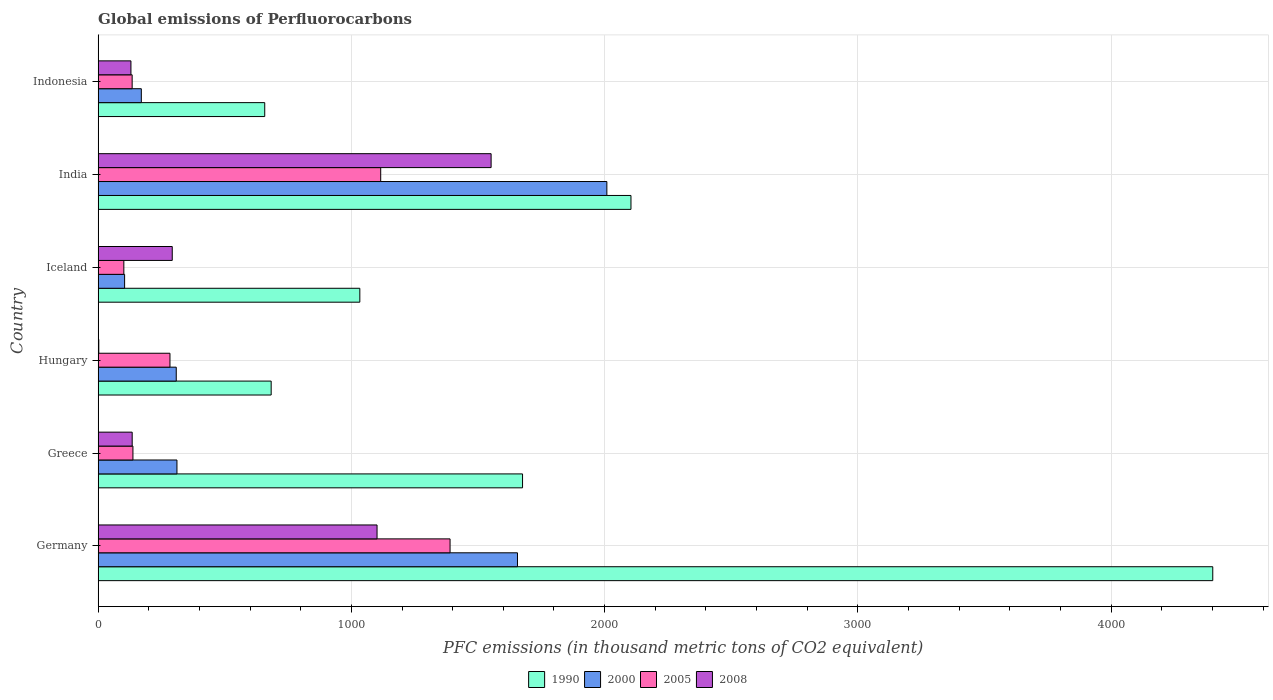Are the number of bars per tick equal to the number of legend labels?
Offer a very short reply. Yes. How many bars are there on the 4th tick from the top?
Provide a succinct answer. 4. What is the label of the 4th group of bars from the top?
Offer a very short reply. Hungary. What is the global emissions of Perfluorocarbons in 2005 in Iceland?
Offer a terse response. 101.6. Across all countries, what is the maximum global emissions of Perfluorocarbons in 2008?
Ensure brevity in your answer.  1551.8. Across all countries, what is the minimum global emissions of Perfluorocarbons in 2005?
Your answer should be compact. 101.6. What is the total global emissions of Perfluorocarbons in 2008 in the graph?
Your answer should be very brief. 3212.7. What is the difference between the global emissions of Perfluorocarbons in 1990 in Greece and that in India?
Ensure brevity in your answer.  -428.1. What is the difference between the global emissions of Perfluorocarbons in 2008 in India and the global emissions of Perfluorocarbons in 2005 in Hungary?
Keep it short and to the point. 1268.1. What is the average global emissions of Perfluorocarbons in 1990 per country?
Give a very brief answer. 1759.3. What is the difference between the global emissions of Perfluorocarbons in 2000 and global emissions of Perfluorocarbons in 2008 in Iceland?
Offer a terse response. -188.1. What is the ratio of the global emissions of Perfluorocarbons in 2000 in Greece to that in India?
Make the answer very short. 0.15. Is the difference between the global emissions of Perfluorocarbons in 2000 in Germany and Greece greater than the difference between the global emissions of Perfluorocarbons in 2008 in Germany and Greece?
Provide a succinct answer. Yes. What is the difference between the highest and the second highest global emissions of Perfluorocarbons in 2000?
Your answer should be compact. 352.9. What is the difference between the highest and the lowest global emissions of Perfluorocarbons in 2008?
Offer a very short reply. 1549.1. In how many countries, is the global emissions of Perfluorocarbons in 1990 greater than the average global emissions of Perfluorocarbons in 1990 taken over all countries?
Ensure brevity in your answer.  2. Is it the case that in every country, the sum of the global emissions of Perfluorocarbons in 2000 and global emissions of Perfluorocarbons in 2008 is greater than the sum of global emissions of Perfluorocarbons in 2005 and global emissions of Perfluorocarbons in 1990?
Your response must be concise. No. What does the 4th bar from the top in Hungary represents?
Provide a short and direct response. 1990. How many bars are there?
Offer a terse response. 24. Are all the bars in the graph horizontal?
Provide a short and direct response. Yes. What is the difference between two consecutive major ticks on the X-axis?
Provide a short and direct response. 1000. Are the values on the major ticks of X-axis written in scientific E-notation?
Make the answer very short. No. What is the title of the graph?
Keep it short and to the point. Global emissions of Perfluorocarbons. What is the label or title of the X-axis?
Make the answer very short. PFC emissions (in thousand metric tons of CO2 equivalent). What is the PFC emissions (in thousand metric tons of CO2 equivalent) in 1990 in Germany?
Give a very brief answer. 4401.3. What is the PFC emissions (in thousand metric tons of CO2 equivalent) of 2000 in Germany?
Give a very brief answer. 1655.9. What is the PFC emissions (in thousand metric tons of CO2 equivalent) in 2005 in Germany?
Offer a terse response. 1389.7. What is the PFC emissions (in thousand metric tons of CO2 equivalent) of 2008 in Germany?
Provide a short and direct response. 1101.4. What is the PFC emissions (in thousand metric tons of CO2 equivalent) of 1990 in Greece?
Your answer should be compact. 1675.9. What is the PFC emissions (in thousand metric tons of CO2 equivalent) of 2000 in Greece?
Ensure brevity in your answer.  311.3. What is the PFC emissions (in thousand metric tons of CO2 equivalent) in 2005 in Greece?
Your answer should be very brief. 137.5. What is the PFC emissions (in thousand metric tons of CO2 equivalent) in 2008 in Greece?
Your response must be concise. 134.5. What is the PFC emissions (in thousand metric tons of CO2 equivalent) in 1990 in Hungary?
Give a very brief answer. 683.3. What is the PFC emissions (in thousand metric tons of CO2 equivalent) in 2000 in Hungary?
Your answer should be very brief. 308.5. What is the PFC emissions (in thousand metric tons of CO2 equivalent) in 2005 in Hungary?
Offer a very short reply. 283.7. What is the PFC emissions (in thousand metric tons of CO2 equivalent) of 1990 in Iceland?
Make the answer very short. 1033.4. What is the PFC emissions (in thousand metric tons of CO2 equivalent) of 2000 in Iceland?
Make the answer very short. 104.6. What is the PFC emissions (in thousand metric tons of CO2 equivalent) of 2005 in Iceland?
Keep it short and to the point. 101.6. What is the PFC emissions (in thousand metric tons of CO2 equivalent) in 2008 in Iceland?
Ensure brevity in your answer.  292.7. What is the PFC emissions (in thousand metric tons of CO2 equivalent) in 1990 in India?
Offer a terse response. 2104. What is the PFC emissions (in thousand metric tons of CO2 equivalent) of 2000 in India?
Your answer should be very brief. 2008.8. What is the PFC emissions (in thousand metric tons of CO2 equivalent) of 2005 in India?
Ensure brevity in your answer.  1115.8. What is the PFC emissions (in thousand metric tons of CO2 equivalent) in 2008 in India?
Provide a succinct answer. 1551.8. What is the PFC emissions (in thousand metric tons of CO2 equivalent) in 1990 in Indonesia?
Make the answer very short. 657.9. What is the PFC emissions (in thousand metric tons of CO2 equivalent) in 2000 in Indonesia?
Give a very brief answer. 170.6. What is the PFC emissions (in thousand metric tons of CO2 equivalent) of 2005 in Indonesia?
Your response must be concise. 134.4. What is the PFC emissions (in thousand metric tons of CO2 equivalent) of 2008 in Indonesia?
Make the answer very short. 129.6. Across all countries, what is the maximum PFC emissions (in thousand metric tons of CO2 equivalent) of 1990?
Make the answer very short. 4401.3. Across all countries, what is the maximum PFC emissions (in thousand metric tons of CO2 equivalent) of 2000?
Offer a very short reply. 2008.8. Across all countries, what is the maximum PFC emissions (in thousand metric tons of CO2 equivalent) of 2005?
Offer a very short reply. 1389.7. Across all countries, what is the maximum PFC emissions (in thousand metric tons of CO2 equivalent) of 2008?
Your answer should be very brief. 1551.8. Across all countries, what is the minimum PFC emissions (in thousand metric tons of CO2 equivalent) of 1990?
Give a very brief answer. 657.9. Across all countries, what is the minimum PFC emissions (in thousand metric tons of CO2 equivalent) of 2000?
Offer a very short reply. 104.6. Across all countries, what is the minimum PFC emissions (in thousand metric tons of CO2 equivalent) in 2005?
Your answer should be very brief. 101.6. Across all countries, what is the minimum PFC emissions (in thousand metric tons of CO2 equivalent) in 2008?
Ensure brevity in your answer.  2.7. What is the total PFC emissions (in thousand metric tons of CO2 equivalent) of 1990 in the graph?
Offer a terse response. 1.06e+04. What is the total PFC emissions (in thousand metric tons of CO2 equivalent) of 2000 in the graph?
Ensure brevity in your answer.  4559.7. What is the total PFC emissions (in thousand metric tons of CO2 equivalent) of 2005 in the graph?
Keep it short and to the point. 3162.7. What is the total PFC emissions (in thousand metric tons of CO2 equivalent) in 2008 in the graph?
Make the answer very short. 3212.7. What is the difference between the PFC emissions (in thousand metric tons of CO2 equivalent) in 1990 in Germany and that in Greece?
Provide a succinct answer. 2725.4. What is the difference between the PFC emissions (in thousand metric tons of CO2 equivalent) of 2000 in Germany and that in Greece?
Offer a terse response. 1344.6. What is the difference between the PFC emissions (in thousand metric tons of CO2 equivalent) in 2005 in Germany and that in Greece?
Your answer should be compact. 1252.2. What is the difference between the PFC emissions (in thousand metric tons of CO2 equivalent) in 2008 in Germany and that in Greece?
Make the answer very short. 966.9. What is the difference between the PFC emissions (in thousand metric tons of CO2 equivalent) of 1990 in Germany and that in Hungary?
Your answer should be very brief. 3718. What is the difference between the PFC emissions (in thousand metric tons of CO2 equivalent) in 2000 in Germany and that in Hungary?
Keep it short and to the point. 1347.4. What is the difference between the PFC emissions (in thousand metric tons of CO2 equivalent) in 2005 in Germany and that in Hungary?
Make the answer very short. 1106. What is the difference between the PFC emissions (in thousand metric tons of CO2 equivalent) of 2008 in Germany and that in Hungary?
Give a very brief answer. 1098.7. What is the difference between the PFC emissions (in thousand metric tons of CO2 equivalent) of 1990 in Germany and that in Iceland?
Your answer should be very brief. 3367.9. What is the difference between the PFC emissions (in thousand metric tons of CO2 equivalent) of 2000 in Germany and that in Iceland?
Give a very brief answer. 1551.3. What is the difference between the PFC emissions (in thousand metric tons of CO2 equivalent) in 2005 in Germany and that in Iceland?
Offer a terse response. 1288.1. What is the difference between the PFC emissions (in thousand metric tons of CO2 equivalent) of 2008 in Germany and that in Iceland?
Offer a terse response. 808.7. What is the difference between the PFC emissions (in thousand metric tons of CO2 equivalent) in 1990 in Germany and that in India?
Ensure brevity in your answer.  2297.3. What is the difference between the PFC emissions (in thousand metric tons of CO2 equivalent) of 2000 in Germany and that in India?
Provide a succinct answer. -352.9. What is the difference between the PFC emissions (in thousand metric tons of CO2 equivalent) of 2005 in Germany and that in India?
Your response must be concise. 273.9. What is the difference between the PFC emissions (in thousand metric tons of CO2 equivalent) of 2008 in Germany and that in India?
Make the answer very short. -450.4. What is the difference between the PFC emissions (in thousand metric tons of CO2 equivalent) of 1990 in Germany and that in Indonesia?
Your response must be concise. 3743.4. What is the difference between the PFC emissions (in thousand metric tons of CO2 equivalent) of 2000 in Germany and that in Indonesia?
Offer a terse response. 1485.3. What is the difference between the PFC emissions (in thousand metric tons of CO2 equivalent) of 2005 in Germany and that in Indonesia?
Keep it short and to the point. 1255.3. What is the difference between the PFC emissions (in thousand metric tons of CO2 equivalent) of 2008 in Germany and that in Indonesia?
Provide a succinct answer. 971.8. What is the difference between the PFC emissions (in thousand metric tons of CO2 equivalent) of 1990 in Greece and that in Hungary?
Offer a very short reply. 992.6. What is the difference between the PFC emissions (in thousand metric tons of CO2 equivalent) of 2005 in Greece and that in Hungary?
Make the answer very short. -146.2. What is the difference between the PFC emissions (in thousand metric tons of CO2 equivalent) in 2008 in Greece and that in Hungary?
Your response must be concise. 131.8. What is the difference between the PFC emissions (in thousand metric tons of CO2 equivalent) of 1990 in Greece and that in Iceland?
Your answer should be very brief. 642.5. What is the difference between the PFC emissions (in thousand metric tons of CO2 equivalent) of 2000 in Greece and that in Iceland?
Your answer should be very brief. 206.7. What is the difference between the PFC emissions (in thousand metric tons of CO2 equivalent) in 2005 in Greece and that in Iceland?
Provide a short and direct response. 35.9. What is the difference between the PFC emissions (in thousand metric tons of CO2 equivalent) in 2008 in Greece and that in Iceland?
Offer a terse response. -158.2. What is the difference between the PFC emissions (in thousand metric tons of CO2 equivalent) in 1990 in Greece and that in India?
Make the answer very short. -428.1. What is the difference between the PFC emissions (in thousand metric tons of CO2 equivalent) in 2000 in Greece and that in India?
Provide a short and direct response. -1697.5. What is the difference between the PFC emissions (in thousand metric tons of CO2 equivalent) of 2005 in Greece and that in India?
Offer a very short reply. -978.3. What is the difference between the PFC emissions (in thousand metric tons of CO2 equivalent) of 2008 in Greece and that in India?
Give a very brief answer. -1417.3. What is the difference between the PFC emissions (in thousand metric tons of CO2 equivalent) of 1990 in Greece and that in Indonesia?
Offer a very short reply. 1018. What is the difference between the PFC emissions (in thousand metric tons of CO2 equivalent) in 2000 in Greece and that in Indonesia?
Your answer should be very brief. 140.7. What is the difference between the PFC emissions (in thousand metric tons of CO2 equivalent) of 2005 in Greece and that in Indonesia?
Make the answer very short. 3.1. What is the difference between the PFC emissions (in thousand metric tons of CO2 equivalent) of 2008 in Greece and that in Indonesia?
Provide a short and direct response. 4.9. What is the difference between the PFC emissions (in thousand metric tons of CO2 equivalent) of 1990 in Hungary and that in Iceland?
Ensure brevity in your answer.  -350.1. What is the difference between the PFC emissions (in thousand metric tons of CO2 equivalent) in 2000 in Hungary and that in Iceland?
Provide a succinct answer. 203.9. What is the difference between the PFC emissions (in thousand metric tons of CO2 equivalent) in 2005 in Hungary and that in Iceland?
Your answer should be very brief. 182.1. What is the difference between the PFC emissions (in thousand metric tons of CO2 equivalent) of 2008 in Hungary and that in Iceland?
Your response must be concise. -290. What is the difference between the PFC emissions (in thousand metric tons of CO2 equivalent) of 1990 in Hungary and that in India?
Offer a terse response. -1420.7. What is the difference between the PFC emissions (in thousand metric tons of CO2 equivalent) in 2000 in Hungary and that in India?
Give a very brief answer. -1700.3. What is the difference between the PFC emissions (in thousand metric tons of CO2 equivalent) of 2005 in Hungary and that in India?
Your answer should be compact. -832.1. What is the difference between the PFC emissions (in thousand metric tons of CO2 equivalent) in 2008 in Hungary and that in India?
Provide a short and direct response. -1549.1. What is the difference between the PFC emissions (in thousand metric tons of CO2 equivalent) of 1990 in Hungary and that in Indonesia?
Give a very brief answer. 25.4. What is the difference between the PFC emissions (in thousand metric tons of CO2 equivalent) in 2000 in Hungary and that in Indonesia?
Provide a succinct answer. 137.9. What is the difference between the PFC emissions (in thousand metric tons of CO2 equivalent) in 2005 in Hungary and that in Indonesia?
Your answer should be very brief. 149.3. What is the difference between the PFC emissions (in thousand metric tons of CO2 equivalent) of 2008 in Hungary and that in Indonesia?
Give a very brief answer. -126.9. What is the difference between the PFC emissions (in thousand metric tons of CO2 equivalent) in 1990 in Iceland and that in India?
Provide a short and direct response. -1070.6. What is the difference between the PFC emissions (in thousand metric tons of CO2 equivalent) of 2000 in Iceland and that in India?
Offer a terse response. -1904.2. What is the difference between the PFC emissions (in thousand metric tons of CO2 equivalent) of 2005 in Iceland and that in India?
Your answer should be compact. -1014.2. What is the difference between the PFC emissions (in thousand metric tons of CO2 equivalent) of 2008 in Iceland and that in India?
Offer a terse response. -1259.1. What is the difference between the PFC emissions (in thousand metric tons of CO2 equivalent) of 1990 in Iceland and that in Indonesia?
Your answer should be very brief. 375.5. What is the difference between the PFC emissions (in thousand metric tons of CO2 equivalent) of 2000 in Iceland and that in Indonesia?
Keep it short and to the point. -66. What is the difference between the PFC emissions (in thousand metric tons of CO2 equivalent) in 2005 in Iceland and that in Indonesia?
Provide a succinct answer. -32.8. What is the difference between the PFC emissions (in thousand metric tons of CO2 equivalent) of 2008 in Iceland and that in Indonesia?
Offer a terse response. 163.1. What is the difference between the PFC emissions (in thousand metric tons of CO2 equivalent) of 1990 in India and that in Indonesia?
Offer a very short reply. 1446.1. What is the difference between the PFC emissions (in thousand metric tons of CO2 equivalent) of 2000 in India and that in Indonesia?
Your response must be concise. 1838.2. What is the difference between the PFC emissions (in thousand metric tons of CO2 equivalent) of 2005 in India and that in Indonesia?
Offer a terse response. 981.4. What is the difference between the PFC emissions (in thousand metric tons of CO2 equivalent) of 2008 in India and that in Indonesia?
Ensure brevity in your answer.  1422.2. What is the difference between the PFC emissions (in thousand metric tons of CO2 equivalent) of 1990 in Germany and the PFC emissions (in thousand metric tons of CO2 equivalent) of 2000 in Greece?
Keep it short and to the point. 4090. What is the difference between the PFC emissions (in thousand metric tons of CO2 equivalent) of 1990 in Germany and the PFC emissions (in thousand metric tons of CO2 equivalent) of 2005 in Greece?
Offer a very short reply. 4263.8. What is the difference between the PFC emissions (in thousand metric tons of CO2 equivalent) in 1990 in Germany and the PFC emissions (in thousand metric tons of CO2 equivalent) in 2008 in Greece?
Your answer should be very brief. 4266.8. What is the difference between the PFC emissions (in thousand metric tons of CO2 equivalent) of 2000 in Germany and the PFC emissions (in thousand metric tons of CO2 equivalent) of 2005 in Greece?
Offer a very short reply. 1518.4. What is the difference between the PFC emissions (in thousand metric tons of CO2 equivalent) in 2000 in Germany and the PFC emissions (in thousand metric tons of CO2 equivalent) in 2008 in Greece?
Provide a succinct answer. 1521.4. What is the difference between the PFC emissions (in thousand metric tons of CO2 equivalent) in 2005 in Germany and the PFC emissions (in thousand metric tons of CO2 equivalent) in 2008 in Greece?
Offer a terse response. 1255.2. What is the difference between the PFC emissions (in thousand metric tons of CO2 equivalent) of 1990 in Germany and the PFC emissions (in thousand metric tons of CO2 equivalent) of 2000 in Hungary?
Your answer should be compact. 4092.8. What is the difference between the PFC emissions (in thousand metric tons of CO2 equivalent) of 1990 in Germany and the PFC emissions (in thousand metric tons of CO2 equivalent) of 2005 in Hungary?
Offer a terse response. 4117.6. What is the difference between the PFC emissions (in thousand metric tons of CO2 equivalent) in 1990 in Germany and the PFC emissions (in thousand metric tons of CO2 equivalent) in 2008 in Hungary?
Make the answer very short. 4398.6. What is the difference between the PFC emissions (in thousand metric tons of CO2 equivalent) of 2000 in Germany and the PFC emissions (in thousand metric tons of CO2 equivalent) of 2005 in Hungary?
Provide a succinct answer. 1372.2. What is the difference between the PFC emissions (in thousand metric tons of CO2 equivalent) in 2000 in Germany and the PFC emissions (in thousand metric tons of CO2 equivalent) in 2008 in Hungary?
Give a very brief answer. 1653.2. What is the difference between the PFC emissions (in thousand metric tons of CO2 equivalent) in 2005 in Germany and the PFC emissions (in thousand metric tons of CO2 equivalent) in 2008 in Hungary?
Ensure brevity in your answer.  1387. What is the difference between the PFC emissions (in thousand metric tons of CO2 equivalent) of 1990 in Germany and the PFC emissions (in thousand metric tons of CO2 equivalent) of 2000 in Iceland?
Ensure brevity in your answer.  4296.7. What is the difference between the PFC emissions (in thousand metric tons of CO2 equivalent) of 1990 in Germany and the PFC emissions (in thousand metric tons of CO2 equivalent) of 2005 in Iceland?
Provide a short and direct response. 4299.7. What is the difference between the PFC emissions (in thousand metric tons of CO2 equivalent) in 1990 in Germany and the PFC emissions (in thousand metric tons of CO2 equivalent) in 2008 in Iceland?
Your answer should be compact. 4108.6. What is the difference between the PFC emissions (in thousand metric tons of CO2 equivalent) in 2000 in Germany and the PFC emissions (in thousand metric tons of CO2 equivalent) in 2005 in Iceland?
Your response must be concise. 1554.3. What is the difference between the PFC emissions (in thousand metric tons of CO2 equivalent) in 2000 in Germany and the PFC emissions (in thousand metric tons of CO2 equivalent) in 2008 in Iceland?
Your answer should be compact. 1363.2. What is the difference between the PFC emissions (in thousand metric tons of CO2 equivalent) in 2005 in Germany and the PFC emissions (in thousand metric tons of CO2 equivalent) in 2008 in Iceland?
Make the answer very short. 1097. What is the difference between the PFC emissions (in thousand metric tons of CO2 equivalent) of 1990 in Germany and the PFC emissions (in thousand metric tons of CO2 equivalent) of 2000 in India?
Your answer should be compact. 2392.5. What is the difference between the PFC emissions (in thousand metric tons of CO2 equivalent) of 1990 in Germany and the PFC emissions (in thousand metric tons of CO2 equivalent) of 2005 in India?
Offer a terse response. 3285.5. What is the difference between the PFC emissions (in thousand metric tons of CO2 equivalent) of 1990 in Germany and the PFC emissions (in thousand metric tons of CO2 equivalent) of 2008 in India?
Ensure brevity in your answer.  2849.5. What is the difference between the PFC emissions (in thousand metric tons of CO2 equivalent) of 2000 in Germany and the PFC emissions (in thousand metric tons of CO2 equivalent) of 2005 in India?
Give a very brief answer. 540.1. What is the difference between the PFC emissions (in thousand metric tons of CO2 equivalent) of 2000 in Germany and the PFC emissions (in thousand metric tons of CO2 equivalent) of 2008 in India?
Offer a very short reply. 104.1. What is the difference between the PFC emissions (in thousand metric tons of CO2 equivalent) of 2005 in Germany and the PFC emissions (in thousand metric tons of CO2 equivalent) of 2008 in India?
Ensure brevity in your answer.  -162.1. What is the difference between the PFC emissions (in thousand metric tons of CO2 equivalent) of 1990 in Germany and the PFC emissions (in thousand metric tons of CO2 equivalent) of 2000 in Indonesia?
Keep it short and to the point. 4230.7. What is the difference between the PFC emissions (in thousand metric tons of CO2 equivalent) in 1990 in Germany and the PFC emissions (in thousand metric tons of CO2 equivalent) in 2005 in Indonesia?
Keep it short and to the point. 4266.9. What is the difference between the PFC emissions (in thousand metric tons of CO2 equivalent) in 1990 in Germany and the PFC emissions (in thousand metric tons of CO2 equivalent) in 2008 in Indonesia?
Your answer should be compact. 4271.7. What is the difference between the PFC emissions (in thousand metric tons of CO2 equivalent) of 2000 in Germany and the PFC emissions (in thousand metric tons of CO2 equivalent) of 2005 in Indonesia?
Ensure brevity in your answer.  1521.5. What is the difference between the PFC emissions (in thousand metric tons of CO2 equivalent) in 2000 in Germany and the PFC emissions (in thousand metric tons of CO2 equivalent) in 2008 in Indonesia?
Provide a short and direct response. 1526.3. What is the difference between the PFC emissions (in thousand metric tons of CO2 equivalent) in 2005 in Germany and the PFC emissions (in thousand metric tons of CO2 equivalent) in 2008 in Indonesia?
Ensure brevity in your answer.  1260.1. What is the difference between the PFC emissions (in thousand metric tons of CO2 equivalent) of 1990 in Greece and the PFC emissions (in thousand metric tons of CO2 equivalent) of 2000 in Hungary?
Your response must be concise. 1367.4. What is the difference between the PFC emissions (in thousand metric tons of CO2 equivalent) in 1990 in Greece and the PFC emissions (in thousand metric tons of CO2 equivalent) in 2005 in Hungary?
Your answer should be very brief. 1392.2. What is the difference between the PFC emissions (in thousand metric tons of CO2 equivalent) of 1990 in Greece and the PFC emissions (in thousand metric tons of CO2 equivalent) of 2008 in Hungary?
Provide a succinct answer. 1673.2. What is the difference between the PFC emissions (in thousand metric tons of CO2 equivalent) of 2000 in Greece and the PFC emissions (in thousand metric tons of CO2 equivalent) of 2005 in Hungary?
Provide a succinct answer. 27.6. What is the difference between the PFC emissions (in thousand metric tons of CO2 equivalent) in 2000 in Greece and the PFC emissions (in thousand metric tons of CO2 equivalent) in 2008 in Hungary?
Your response must be concise. 308.6. What is the difference between the PFC emissions (in thousand metric tons of CO2 equivalent) of 2005 in Greece and the PFC emissions (in thousand metric tons of CO2 equivalent) of 2008 in Hungary?
Offer a terse response. 134.8. What is the difference between the PFC emissions (in thousand metric tons of CO2 equivalent) in 1990 in Greece and the PFC emissions (in thousand metric tons of CO2 equivalent) in 2000 in Iceland?
Provide a succinct answer. 1571.3. What is the difference between the PFC emissions (in thousand metric tons of CO2 equivalent) of 1990 in Greece and the PFC emissions (in thousand metric tons of CO2 equivalent) of 2005 in Iceland?
Offer a very short reply. 1574.3. What is the difference between the PFC emissions (in thousand metric tons of CO2 equivalent) in 1990 in Greece and the PFC emissions (in thousand metric tons of CO2 equivalent) in 2008 in Iceland?
Make the answer very short. 1383.2. What is the difference between the PFC emissions (in thousand metric tons of CO2 equivalent) in 2000 in Greece and the PFC emissions (in thousand metric tons of CO2 equivalent) in 2005 in Iceland?
Give a very brief answer. 209.7. What is the difference between the PFC emissions (in thousand metric tons of CO2 equivalent) of 2000 in Greece and the PFC emissions (in thousand metric tons of CO2 equivalent) of 2008 in Iceland?
Your answer should be compact. 18.6. What is the difference between the PFC emissions (in thousand metric tons of CO2 equivalent) of 2005 in Greece and the PFC emissions (in thousand metric tons of CO2 equivalent) of 2008 in Iceland?
Ensure brevity in your answer.  -155.2. What is the difference between the PFC emissions (in thousand metric tons of CO2 equivalent) in 1990 in Greece and the PFC emissions (in thousand metric tons of CO2 equivalent) in 2000 in India?
Provide a succinct answer. -332.9. What is the difference between the PFC emissions (in thousand metric tons of CO2 equivalent) in 1990 in Greece and the PFC emissions (in thousand metric tons of CO2 equivalent) in 2005 in India?
Provide a short and direct response. 560.1. What is the difference between the PFC emissions (in thousand metric tons of CO2 equivalent) of 1990 in Greece and the PFC emissions (in thousand metric tons of CO2 equivalent) of 2008 in India?
Ensure brevity in your answer.  124.1. What is the difference between the PFC emissions (in thousand metric tons of CO2 equivalent) in 2000 in Greece and the PFC emissions (in thousand metric tons of CO2 equivalent) in 2005 in India?
Your response must be concise. -804.5. What is the difference between the PFC emissions (in thousand metric tons of CO2 equivalent) of 2000 in Greece and the PFC emissions (in thousand metric tons of CO2 equivalent) of 2008 in India?
Provide a succinct answer. -1240.5. What is the difference between the PFC emissions (in thousand metric tons of CO2 equivalent) of 2005 in Greece and the PFC emissions (in thousand metric tons of CO2 equivalent) of 2008 in India?
Make the answer very short. -1414.3. What is the difference between the PFC emissions (in thousand metric tons of CO2 equivalent) of 1990 in Greece and the PFC emissions (in thousand metric tons of CO2 equivalent) of 2000 in Indonesia?
Give a very brief answer. 1505.3. What is the difference between the PFC emissions (in thousand metric tons of CO2 equivalent) of 1990 in Greece and the PFC emissions (in thousand metric tons of CO2 equivalent) of 2005 in Indonesia?
Provide a short and direct response. 1541.5. What is the difference between the PFC emissions (in thousand metric tons of CO2 equivalent) in 1990 in Greece and the PFC emissions (in thousand metric tons of CO2 equivalent) in 2008 in Indonesia?
Offer a very short reply. 1546.3. What is the difference between the PFC emissions (in thousand metric tons of CO2 equivalent) of 2000 in Greece and the PFC emissions (in thousand metric tons of CO2 equivalent) of 2005 in Indonesia?
Keep it short and to the point. 176.9. What is the difference between the PFC emissions (in thousand metric tons of CO2 equivalent) in 2000 in Greece and the PFC emissions (in thousand metric tons of CO2 equivalent) in 2008 in Indonesia?
Your answer should be very brief. 181.7. What is the difference between the PFC emissions (in thousand metric tons of CO2 equivalent) of 1990 in Hungary and the PFC emissions (in thousand metric tons of CO2 equivalent) of 2000 in Iceland?
Give a very brief answer. 578.7. What is the difference between the PFC emissions (in thousand metric tons of CO2 equivalent) in 1990 in Hungary and the PFC emissions (in thousand metric tons of CO2 equivalent) in 2005 in Iceland?
Provide a short and direct response. 581.7. What is the difference between the PFC emissions (in thousand metric tons of CO2 equivalent) in 1990 in Hungary and the PFC emissions (in thousand metric tons of CO2 equivalent) in 2008 in Iceland?
Your answer should be compact. 390.6. What is the difference between the PFC emissions (in thousand metric tons of CO2 equivalent) in 2000 in Hungary and the PFC emissions (in thousand metric tons of CO2 equivalent) in 2005 in Iceland?
Make the answer very short. 206.9. What is the difference between the PFC emissions (in thousand metric tons of CO2 equivalent) of 2005 in Hungary and the PFC emissions (in thousand metric tons of CO2 equivalent) of 2008 in Iceland?
Provide a succinct answer. -9. What is the difference between the PFC emissions (in thousand metric tons of CO2 equivalent) of 1990 in Hungary and the PFC emissions (in thousand metric tons of CO2 equivalent) of 2000 in India?
Offer a very short reply. -1325.5. What is the difference between the PFC emissions (in thousand metric tons of CO2 equivalent) of 1990 in Hungary and the PFC emissions (in thousand metric tons of CO2 equivalent) of 2005 in India?
Your response must be concise. -432.5. What is the difference between the PFC emissions (in thousand metric tons of CO2 equivalent) of 1990 in Hungary and the PFC emissions (in thousand metric tons of CO2 equivalent) of 2008 in India?
Provide a succinct answer. -868.5. What is the difference between the PFC emissions (in thousand metric tons of CO2 equivalent) of 2000 in Hungary and the PFC emissions (in thousand metric tons of CO2 equivalent) of 2005 in India?
Offer a terse response. -807.3. What is the difference between the PFC emissions (in thousand metric tons of CO2 equivalent) in 2000 in Hungary and the PFC emissions (in thousand metric tons of CO2 equivalent) in 2008 in India?
Make the answer very short. -1243.3. What is the difference between the PFC emissions (in thousand metric tons of CO2 equivalent) in 2005 in Hungary and the PFC emissions (in thousand metric tons of CO2 equivalent) in 2008 in India?
Ensure brevity in your answer.  -1268.1. What is the difference between the PFC emissions (in thousand metric tons of CO2 equivalent) in 1990 in Hungary and the PFC emissions (in thousand metric tons of CO2 equivalent) in 2000 in Indonesia?
Ensure brevity in your answer.  512.7. What is the difference between the PFC emissions (in thousand metric tons of CO2 equivalent) of 1990 in Hungary and the PFC emissions (in thousand metric tons of CO2 equivalent) of 2005 in Indonesia?
Ensure brevity in your answer.  548.9. What is the difference between the PFC emissions (in thousand metric tons of CO2 equivalent) in 1990 in Hungary and the PFC emissions (in thousand metric tons of CO2 equivalent) in 2008 in Indonesia?
Offer a terse response. 553.7. What is the difference between the PFC emissions (in thousand metric tons of CO2 equivalent) of 2000 in Hungary and the PFC emissions (in thousand metric tons of CO2 equivalent) of 2005 in Indonesia?
Give a very brief answer. 174.1. What is the difference between the PFC emissions (in thousand metric tons of CO2 equivalent) in 2000 in Hungary and the PFC emissions (in thousand metric tons of CO2 equivalent) in 2008 in Indonesia?
Offer a very short reply. 178.9. What is the difference between the PFC emissions (in thousand metric tons of CO2 equivalent) in 2005 in Hungary and the PFC emissions (in thousand metric tons of CO2 equivalent) in 2008 in Indonesia?
Provide a succinct answer. 154.1. What is the difference between the PFC emissions (in thousand metric tons of CO2 equivalent) in 1990 in Iceland and the PFC emissions (in thousand metric tons of CO2 equivalent) in 2000 in India?
Provide a short and direct response. -975.4. What is the difference between the PFC emissions (in thousand metric tons of CO2 equivalent) of 1990 in Iceland and the PFC emissions (in thousand metric tons of CO2 equivalent) of 2005 in India?
Your response must be concise. -82.4. What is the difference between the PFC emissions (in thousand metric tons of CO2 equivalent) in 1990 in Iceland and the PFC emissions (in thousand metric tons of CO2 equivalent) in 2008 in India?
Offer a terse response. -518.4. What is the difference between the PFC emissions (in thousand metric tons of CO2 equivalent) in 2000 in Iceland and the PFC emissions (in thousand metric tons of CO2 equivalent) in 2005 in India?
Your response must be concise. -1011.2. What is the difference between the PFC emissions (in thousand metric tons of CO2 equivalent) in 2000 in Iceland and the PFC emissions (in thousand metric tons of CO2 equivalent) in 2008 in India?
Give a very brief answer. -1447.2. What is the difference between the PFC emissions (in thousand metric tons of CO2 equivalent) in 2005 in Iceland and the PFC emissions (in thousand metric tons of CO2 equivalent) in 2008 in India?
Provide a succinct answer. -1450.2. What is the difference between the PFC emissions (in thousand metric tons of CO2 equivalent) in 1990 in Iceland and the PFC emissions (in thousand metric tons of CO2 equivalent) in 2000 in Indonesia?
Your response must be concise. 862.8. What is the difference between the PFC emissions (in thousand metric tons of CO2 equivalent) of 1990 in Iceland and the PFC emissions (in thousand metric tons of CO2 equivalent) of 2005 in Indonesia?
Ensure brevity in your answer.  899. What is the difference between the PFC emissions (in thousand metric tons of CO2 equivalent) in 1990 in Iceland and the PFC emissions (in thousand metric tons of CO2 equivalent) in 2008 in Indonesia?
Give a very brief answer. 903.8. What is the difference between the PFC emissions (in thousand metric tons of CO2 equivalent) in 2000 in Iceland and the PFC emissions (in thousand metric tons of CO2 equivalent) in 2005 in Indonesia?
Keep it short and to the point. -29.8. What is the difference between the PFC emissions (in thousand metric tons of CO2 equivalent) of 1990 in India and the PFC emissions (in thousand metric tons of CO2 equivalent) of 2000 in Indonesia?
Make the answer very short. 1933.4. What is the difference between the PFC emissions (in thousand metric tons of CO2 equivalent) of 1990 in India and the PFC emissions (in thousand metric tons of CO2 equivalent) of 2005 in Indonesia?
Give a very brief answer. 1969.6. What is the difference between the PFC emissions (in thousand metric tons of CO2 equivalent) of 1990 in India and the PFC emissions (in thousand metric tons of CO2 equivalent) of 2008 in Indonesia?
Keep it short and to the point. 1974.4. What is the difference between the PFC emissions (in thousand metric tons of CO2 equivalent) of 2000 in India and the PFC emissions (in thousand metric tons of CO2 equivalent) of 2005 in Indonesia?
Offer a very short reply. 1874.4. What is the difference between the PFC emissions (in thousand metric tons of CO2 equivalent) of 2000 in India and the PFC emissions (in thousand metric tons of CO2 equivalent) of 2008 in Indonesia?
Ensure brevity in your answer.  1879.2. What is the difference between the PFC emissions (in thousand metric tons of CO2 equivalent) of 2005 in India and the PFC emissions (in thousand metric tons of CO2 equivalent) of 2008 in Indonesia?
Ensure brevity in your answer.  986.2. What is the average PFC emissions (in thousand metric tons of CO2 equivalent) in 1990 per country?
Offer a very short reply. 1759.3. What is the average PFC emissions (in thousand metric tons of CO2 equivalent) of 2000 per country?
Give a very brief answer. 759.95. What is the average PFC emissions (in thousand metric tons of CO2 equivalent) of 2005 per country?
Your answer should be compact. 527.12. What is the average PFC emissions (in thousand metric tons of CO2 equivalent) of 2008 per country?
Provide a short and direct response. 535.45. What is the difference between the PFC emissions (in thousand metric tons of CO2 equivalent) of 1990 and PFC emissions (in thousand metric tons of CO2 equivalent) of 2000 in Germany?
Keep it short and to the point. 2745.4. What is the difference between the PFC emissions (in thousand metric tons of CO2 equivalent) of 1990 and PFC emissions (in thousand metric tons of CO2 equivalent) of 2005 in Germany?
Provide a short and direct response. 3011.6. What is the difference between the PFC emissions (in thousand metric tons of CO2 equivalent) in 1990 and PFC emissions (in thousand metric tons of CO2 equivalent) in 2008 in Germany?
Make the answer very short. 3299.9. What is the difference between the PFC emissions (in thousand metric tons of CO2 equivalent) of 2000 and PFC emissions (in thousand metric tons of CO2 equivalent) of 2005 in Germany?
Offer a terse response. 266.2. What is the difference between the PFC emissions (in thousand metric tons of CO2 equivalent) in 2000 and PFC emissions (in thousand metric tons of CO2 equivalent) in 2008 in Germany?
Offer a very short reply. 554.5. What is the difference between the PFC emissions (in thousand metric tons of CO2 equivalent) in 2005 and PFC emissions (in thousand metric tons of CO2 equivalent) in 2008 in Germany?
Make the answer very short. 288.3. What is the difference between the PFC emissions (in thousand metric tons of CO2 equivalent) of 1990 and PFC emissions (in thousand metric tons of CO2 equivalent) of 2000 in Greece?
Offer a very short reply. 1364.6. What is the difference between the PFC emissions (in thousand metric tons of CO2 equivalent) of 1990 and PFC emissions (in thousand metric tons of CO2 equivalent) of 2005 in Greece?
Provide a succinct answer. 1538.4. What is the difference between the PFC emissions (in thousand metric tons of CO2 equivalent) of 1990 and PFC emissions (in thousand metric tons of CO2 equivalent) of 2008 in Greece?
Your response must be concise. 1541.4. What is the difference between the PFC emissions (in thousand metric tons of CO2 equivalent) of 2000 and PFC emissions (in thousand metric tons of CO2 equivalent) of 2005 in Greece?
Your answer should be very brief. 173.8. What is the difference between the PFC emissions (in thousand metric tons of CO2 equivalent) in 2000 and PFC emissions (in thousand metric tons of CO2 equivalent) in 2008 in Greece?
Give a very brief answer. 176.8. What is the difference between the PFC emissions (in thousand metric tons of CO2 equivalent) in 2005 and PFC emissions (in thousand metric tons of CO2 equivalent) in 2008 in Greece?
Provide a succinct answer. 3. What is the difference between the PFC emissions (in thousand metric tons of CO2 equivalent) of 1990 and PFC emissions (in thousand metric tons of CO2 equivalent) of 2000 in Hungary?
Ensure brevity in your answer.  374.8. What is the difference between the PFC emissions (in thousand metric tons of CO2 equivalent) of 1990 and PFC emissions (in thousand metric tons of CO2 equivalent) of 2005 in Hungary?
Make the answer very short. 399.6. What is the difference between the PFC emissions (in thousand metric tons of CO2 equivalent) in 1990 and PFC emissions (in thousand metric tons of CO2 equivalent) in 2008 in Hungary?
Keep it short and to the point. 680.6. What is the difference between the PFC emissions (in thousand metric tons of CO2 equivalent) in 2000 and PFC emissions (in thousand metric tons of CO2 equivalent) in 2005 in Hungary?
Your answer should be very brief. 24.8. What is the difference between the PFC emissions (in thousand metric tons of CO2 equivalent) in 2000 and PFC emissions (in thousand metric tons of CO2 equivalent) in 2008 in Hungary?
Offer a terse response. 305.8. What is the difference between the PFC emissions (in thousand metric tons of CO2 equivalent) of 2005 and PFC emissions (in thousand metric tons of CO2 equivalent) of 2008 in Hungary?
Ensure brevity in your answer.  281. What is the difference between the PFC emissions (in thousand metric tons of CO2 equivalent) in 1990 and PFC emissions (in thousand metric tons of CO2 equivalent) in 2000 in Iceland?
Your answer should be compact. 928.8. What is the difference between the PFC emissions (in thousand metric tons of CO2 equivalent) of 1990 and PFC emissions (in thousand metric tons of CO2 equivalent) of 2005 in Iceland?
Make the answer very short. 931.8. What is the difference between the PFC emissions (in thousand metric tons of CO2 equivalent) in 1990 and PFC emissions (in thousand metric tons of CO2 equivalent) in 2008 in Iceland?
Offer a terse response. 740.7. What is the difference between the PFC emissions (in thousand metric tons of CO2 equivalent) of 2000 and PFC emissions (in thousand metric tons of CO2 equivalent) of 2008 in Iceland?
Provide a succinct answer. -188.1. What is the difference between the PFC emissions (in thousand metric tons of CO2 equivalent) of 2005 and PFC emissions (in thousand metric tons of CO2 equivalent) of 2008 in Iceland?
Your answer should be compact. -191.1. What is the difference between the PFC emissions (in thousand metric tons of CO2 equivalent) in 1990 and PFC emissions (in thousand metric tons of CO2 equivalent) in 2000 in India?
Your response must be concise. 95.2. What is the difference between the PFC emissions (in thousand metric tons of CO2 equivalent) in 1990 and PFC emissions (in thousand metric tons of CO2 equivalent) in 2005 in India?
Provide a succinct answer. 988.2. What is the difference between the PFC emissions (in thousand metric tons of CO2 equivalent) in 1990 and PFC emissions (in thousand metric tons of CO2 equivalent) in 2008 in India?
Keep it short and to the point. 552.2. What is the difference between the PFC emissions (in thousand metric tons of CO2 equivalent) of 2000 and PFC emissions (in thousand metric tons of CO2 equivalent) of 2005 in India?
Keep it short and to the point. 893. What is the difference between the PFC emissions (in thousand metric tons of CO2 equivalent) of 2000 and PFC emissions (in thousand metric tons of CO2 equivalent) of 2008 in India?
Give a very brief answer. 457. What is the difference between the PFC emissions (in thousand metric tons of CO2 equivalent) in 2005 and PFC emissions (in thousand metric tons of CO2 equivalent) in 2008 in India?
Provide a succinct answer. -436. What is the difference between the PFC emissions (in thousand metric tons of CO2 equivalent) in 1990 and PFC emissions (in thousand metric tons of CO2 equivalent) in 2000 in Indonesia?
Give a very brief answer. 487.3. What is the difference between the PFC emissions (in thousand metric tons of CO2 equivalent) in 1990 and PFC emissions (in thousand metric tons of CO2 equivalent) in 2005 in Indonesia?
Your response must be concise. 523.5. What is the difference between the PFC emissions (in thousand metric tons of CO2 equivalent) of 1990 and PFC emissions (in thousand metric tons of CO2 equivalent) of 2008 in Indonesia?
Offer a very short reply. 528.3. What is the difference between the PFC emissions (in thousand metric tons of CO2 equivalent) of 2000 and PFC emissions (in thousand metric tons of CO2 equivalent) of 2005 in Indonesia?
Keep it short and to the point. 36.2. What is the ratio of the PFC emissions (in thousand metric tons of CO2 equivalent) of 1990 in Germany to that in Greece?
Ensure brevity in your answer.  2.63. What is the ratio of the PFC emissions (in thousand metric tons of CO2 equivalent) in 2000 in Germany to that in Greece?
Offer a terse response. 5.32. What is the ratio of the PFC emissions (in thousand metric tons of CO2 equivalent) of 2005 in Germany to that in Greece?
Keep it short and to the point. 10.11. What is the ratio of the PFC emissions (in thousand metric tons of CO2 equivalent) of 2008 in Germany to that in Greece?
Ensure brevity in your answer.  8.19. What is the ratio of the PFC emissions (in thousand metric tons of CO2 equivalent) in 1990 in Germany to that in Hungary?
Your answer should be very brief. 6.44. What is the ratio of the PFC emissions (in thousand metric tons of CO2 equivalent) in 2000 in Germany to that in Hungary?
Ensure brevity in your answer.  5.37. What is the ratio of the PFC emissions (in thousand metric tons of CO2 equivalent) in 2005 in Germany to that in Hungary?
Your answer should be compact. 4.9. What is the ratio of the PFC emissions (in thousand metric tons of CO2 equivalent) in 2008 in Germany to that in Hungary?
Provide a succinct answer. 407.93. What is the ratio of the PFC emissions (in thousand metric tons of CO2 equivalent) in 1990 in Germany to that in Iceland?
Offer a terse response. 4.26. What is the ratio of the PFC emissions (in thousand metric tons of CO2 equivalent) of 2000 in Germany to that in Iceland?
Offer a very short reply. 15.83. What is the ratio of the PFC emissions (in thousand metric tons of CO2 equivalent) in 2005 in Germany to that in Iceland?
Your answer should be very brief. 13.68. What is the ratio of the PFC emissions (in thousand metric tons of CO2 equivalent) of 2008 in Germany to that in Iceland?
Give a very brief answer. 3.76. What is the ratio of the PFC emissions (in thousand metric tons of CO2 equivalent) in 1990 in Germany to that in India?
Offer a very short reply. 2.09. What is the ratio of the PFC emissions (in thousand metric tons of CO2 equivalent) in 2000 in Germany to that in India?
Your response must be concise. 0.82. What is the ratio of the PFC emissions (in thousand metric tons of CO2 equivalent) of 2005 in Germany to that in India?
Offer a terse response. 1.25. What is the ratio of the PFC emissions (in thousand metric tons of CO2 equivalent) in 2008 in Germany to that in India?
Provide a short and direct response. 0.71. What is the ratio of the PFC emissions (in thousand metric tons of CO2 equivalent) in 1990 in Germany to that in Indonesia?
Your answer should be compact. 6.69. What is the ratio of the PFC emissions (in thousand metric tons of CO2 equivalent) of 2000 in Germany to that in Indonesia?
Provide a succinct answer. 9.71. What is the ratio of the PFC emissions (in thousand metric tons of CO2 equivalent) in 2005 in Germany to that in Indonesia?
Your answer should be very brief. 10.34. What is the ratio of the PFC emissions (in thousand metric tons of CO2 equivalent) in 2008 in Germany to that in Indonesia?
Ensure brevity in your answer.  8.5. What is the ratio of the PFC emissions (in thousand metric tons of CO2 equivalent) of 1990 in Greece to that in Hungary?
Offer a very short reply. 2.45. What is the ratio of the PFC emissions (in thousand metric tons of CO2 equivalent) in 2000 in Greece to that in Hungary?
Provide a succinct answer. 1.01. What is the ratio of the PFC emissions (in thousand metric tons of CO2 equivalent) in 2005 in Greece to that in Hungary?
Your answer should be compact. 0.48. What is the ratio of the PFC emissions (in thousand metric tons of CO2 equivalent) in 2008 in Greece to that in Hungary?
Offer a very short reply. 49.81. What is the ratio of the PFC emissions (in thousand metric tons of CO2 equivalent) in 1990 in Greece to that in Iceland?
Offer a very short reply. 1.62. What is the ratio of the PFC emissions (in thousand metric tons of CO2 equivalent) in 2000 in Greece to that in Iceland?
Provide a succinct answer. 2.98. What is the ratio of the PFC emissions (in thousand metric tons of CO2 equivalent) in 2005 in Greece to that in Iceland?
Provide a succinct answer. 1.35. What is the ratio of the PFC emissions (in thousand metric tons of CO2 equivalent) in 2008 in Greece to that in Iceland?
Your response must be concise. 0.46. What is the ratio of the PFC emissions (in thousand metric tons of CO2 equivalent) of 1990 in Greece to that in India?
Provide a short and direct response. 0.8. What is the ratio of the PFC emissions (in thousand metric tons of CO2 equivalent) of 2000 in Greece to that in India?
Offer a very short reply. 0.15. What is the ratio of the PFC emissions (in thousand metric tons of CO2 equivalent) in 2005 in Greece to that in India?
Your answer should be very brief. 0.12. What is the ratio of the PFC emissions (in thousand metric tons of CO2 equivalent) of 2008 in Greece to that in India?
Provide a succinct answer. 0.09. What is the ratio of the PFC emissions (in thousand metric tons of CO2 equivalent) of 1990 in Greece to that in Indonesia?
Offer a very short reply. 2.55. What is the ratio of the PFC emissions (in thousand metric tons of CO2 equivalent) in 2000 in Greece to that in Indonesia?
Your answer should be compact. 1.82. What is the ratio of the PFC emissions (in thousand metric tons of CO2 equivalent) of 2005 in Greece to that in Indonesia?
Offer a terse response. 1.02. What is the ratio of the PFC emissions (in thousand metric tons of CO2 equivalent) of 2008 in Greece to that in Indonesia?
Your answer should be compact. 1.04. What is the ratio of the PFC emissions (in thousand metric tons of CO2 equivalent) of 1990 in Hungary to that in Iceland?
Make the answer very short. 0.66. What is the ratio of the PFC emissions (in thousand metric tons of CO2 equivalent) in 2000 in Hungary to that in Iceland?
Provide a short and direct response. 2.95. What is the ratio of the PFC emissions (in thousand metric tons of CO2 equivalent) in 2005 in Hungary to that in Iceland?
Give a very brief answer. 2.79. What is the ratio of the PFC emissions (in thousand metric tons of CO2 equivalent) in 2008 in Hungary to that in Iceland?
Make the answer very short. 0.01. What is the ratio of the PFC emissions (in thousand metric tons of CO2 equivalent) of 1990 in Hungary to that in India?
Your response must be concise. 0.32. What is the ratio of the PFC emissions (in thousand metric tons of CO2 equivalent) of 2000 in Hungary to that in India?
Offer a terse response. 0.15. What is the ratio of the PFC emissions (in thousand metric tons of CO2 equivalent) in 2005 in Hungary to that in India?
Your answer should be compact. 0.25. What is the ratio of the PFC emissions (in thousand metric tons of CO2 equivalent) in 2008 in Hungary to that in India?
Give a very brief answer. 0. What is the ratio of the PFC emissions (in thousand metric tons of CO2 equivalent) in 1990 in Hungary to that in Indonesia?
Your response must be concise. 1.04. What is the ratio of the PFC emissions (in thousand metric tons of CO2 equivalent) of 2000 in Hungary to that in Indonesia?
Offer a very short reply. 1.81. What is the ratio of the PFC emissions (in thousand metric tons of CO2 equivalent) in 2005 in Hungary to that in Indonesia?
Your response must be concise. 2.11. What is the ratio of the PFC emissions (in thousand metric tons of CO2 equivalent) of 2008 in Hungary to that in Indonesia?
Your answer should be compact. 0.02. What is the ratio of the PFC emissions (in thousand metric tons of CO2 equivalent) in 1990 in Iceland to that in India?
Offer a very short reply. 0.49. What is the ratio of the PFC emissions (in thousand metric tons of CO2 equivalent) of 2000 in Iceland to that in India?
Make the answer very short. 0.05. What is the ratio of the PFC emissions (in thousand metric tons of CO2 equivalent) in 2005 in Iceland to that in India?
Make the answer very short. 0.09. What is the ratio of the PFC emissions (in thousand metric tons of CO2 equivalent) in 2008 in Iceland to that in India?
Keep it short and to the point. 0.19. What is the ratio of the PFC emissions (in thousand metric tons of CO2 equivalent) of 1990 in Iceland to that in Indonesia?
Make the answer very short. 1.57. What is the ratio of the PFC emissions (in thousand metric tons of CO2 equivalent) of 2000 in Iceland to that in Indonesia?
Provide a succinct answer. 0.61. What is the ratio of the PFC emissions (in thousand metric tons of CO2 equivalent) of 2005 in Iceland to that in Indonesia?
Make the answer very short. 0.76. What is the ratio of the PFC emissions (in thousand metric tons of CO2 equivalent) in 2008 in Iceland to that in Indonesia?
Your response must be concise. 2.26. What is the ratio of the PFC emissions (in thousand metric tons of CO2 equivalent) of 1990 in India to that in Indonesia?
Make the answer very short. 3.2. What is the ratio of the PFC emissions (in thousand metric tons of CO2 equivalent) in 2000 in India to that in Indonesia?
Your answer should be compact. 11.77. What is the ratio of the PFC emissions (in thousand metric tons of CO2 equivalent) of 2005 in India to that in Indonesia?
Your answer should be very brief. 8.3. What is the ratio of the PFC emissions (in thousand metric tons of CO2 equivalent) of 2008 in India to that in Indonesia?
Your response must be concise. 11.97. What is the difference between the highest and the second highest PFC emissions (in thousand metric tons of CO2 equivalent) in 1990?
Provide a succinct answer. 2297.3. What is the difference between the highest and the second highest PFC emissions (in thousand metric tons of CO2 equivalent) in 2000?
Offer a terse response. 352.9. What is the difference between the highest and the second highest PFC emissions (in thousand metric tons of CO2 equivalent) of 2005?
Offer a very short reply. 273.9. What is the difference between the highest and the second highest PFC emissions (in thousand metric tons of CO2 equivalent) in 2008?
Your answer should be very brief. 450.4. What is the difference between the highest and the lowest PFC emissions (in thousand metric tons of CO2 equivalent) of 1990?
Offer a very short reply. 3743.4. What is the difference between the highest and the lowest PFC emissions (in thousand metric tons of CO2 equivalent) of 2000?
Give a very brief answer. 1904.2. What is the difference between the highest and the lowest PFC emissions (in thousand metric tons of CO2 equivalent) of 2005?
Provide a succinct answer. 1288.1. What is the difference between the highest and the lowest PFC emissions (in thousand metric tons of CO2 equivalent) in 2008?
Your answer should be very brief. 1549.1. 